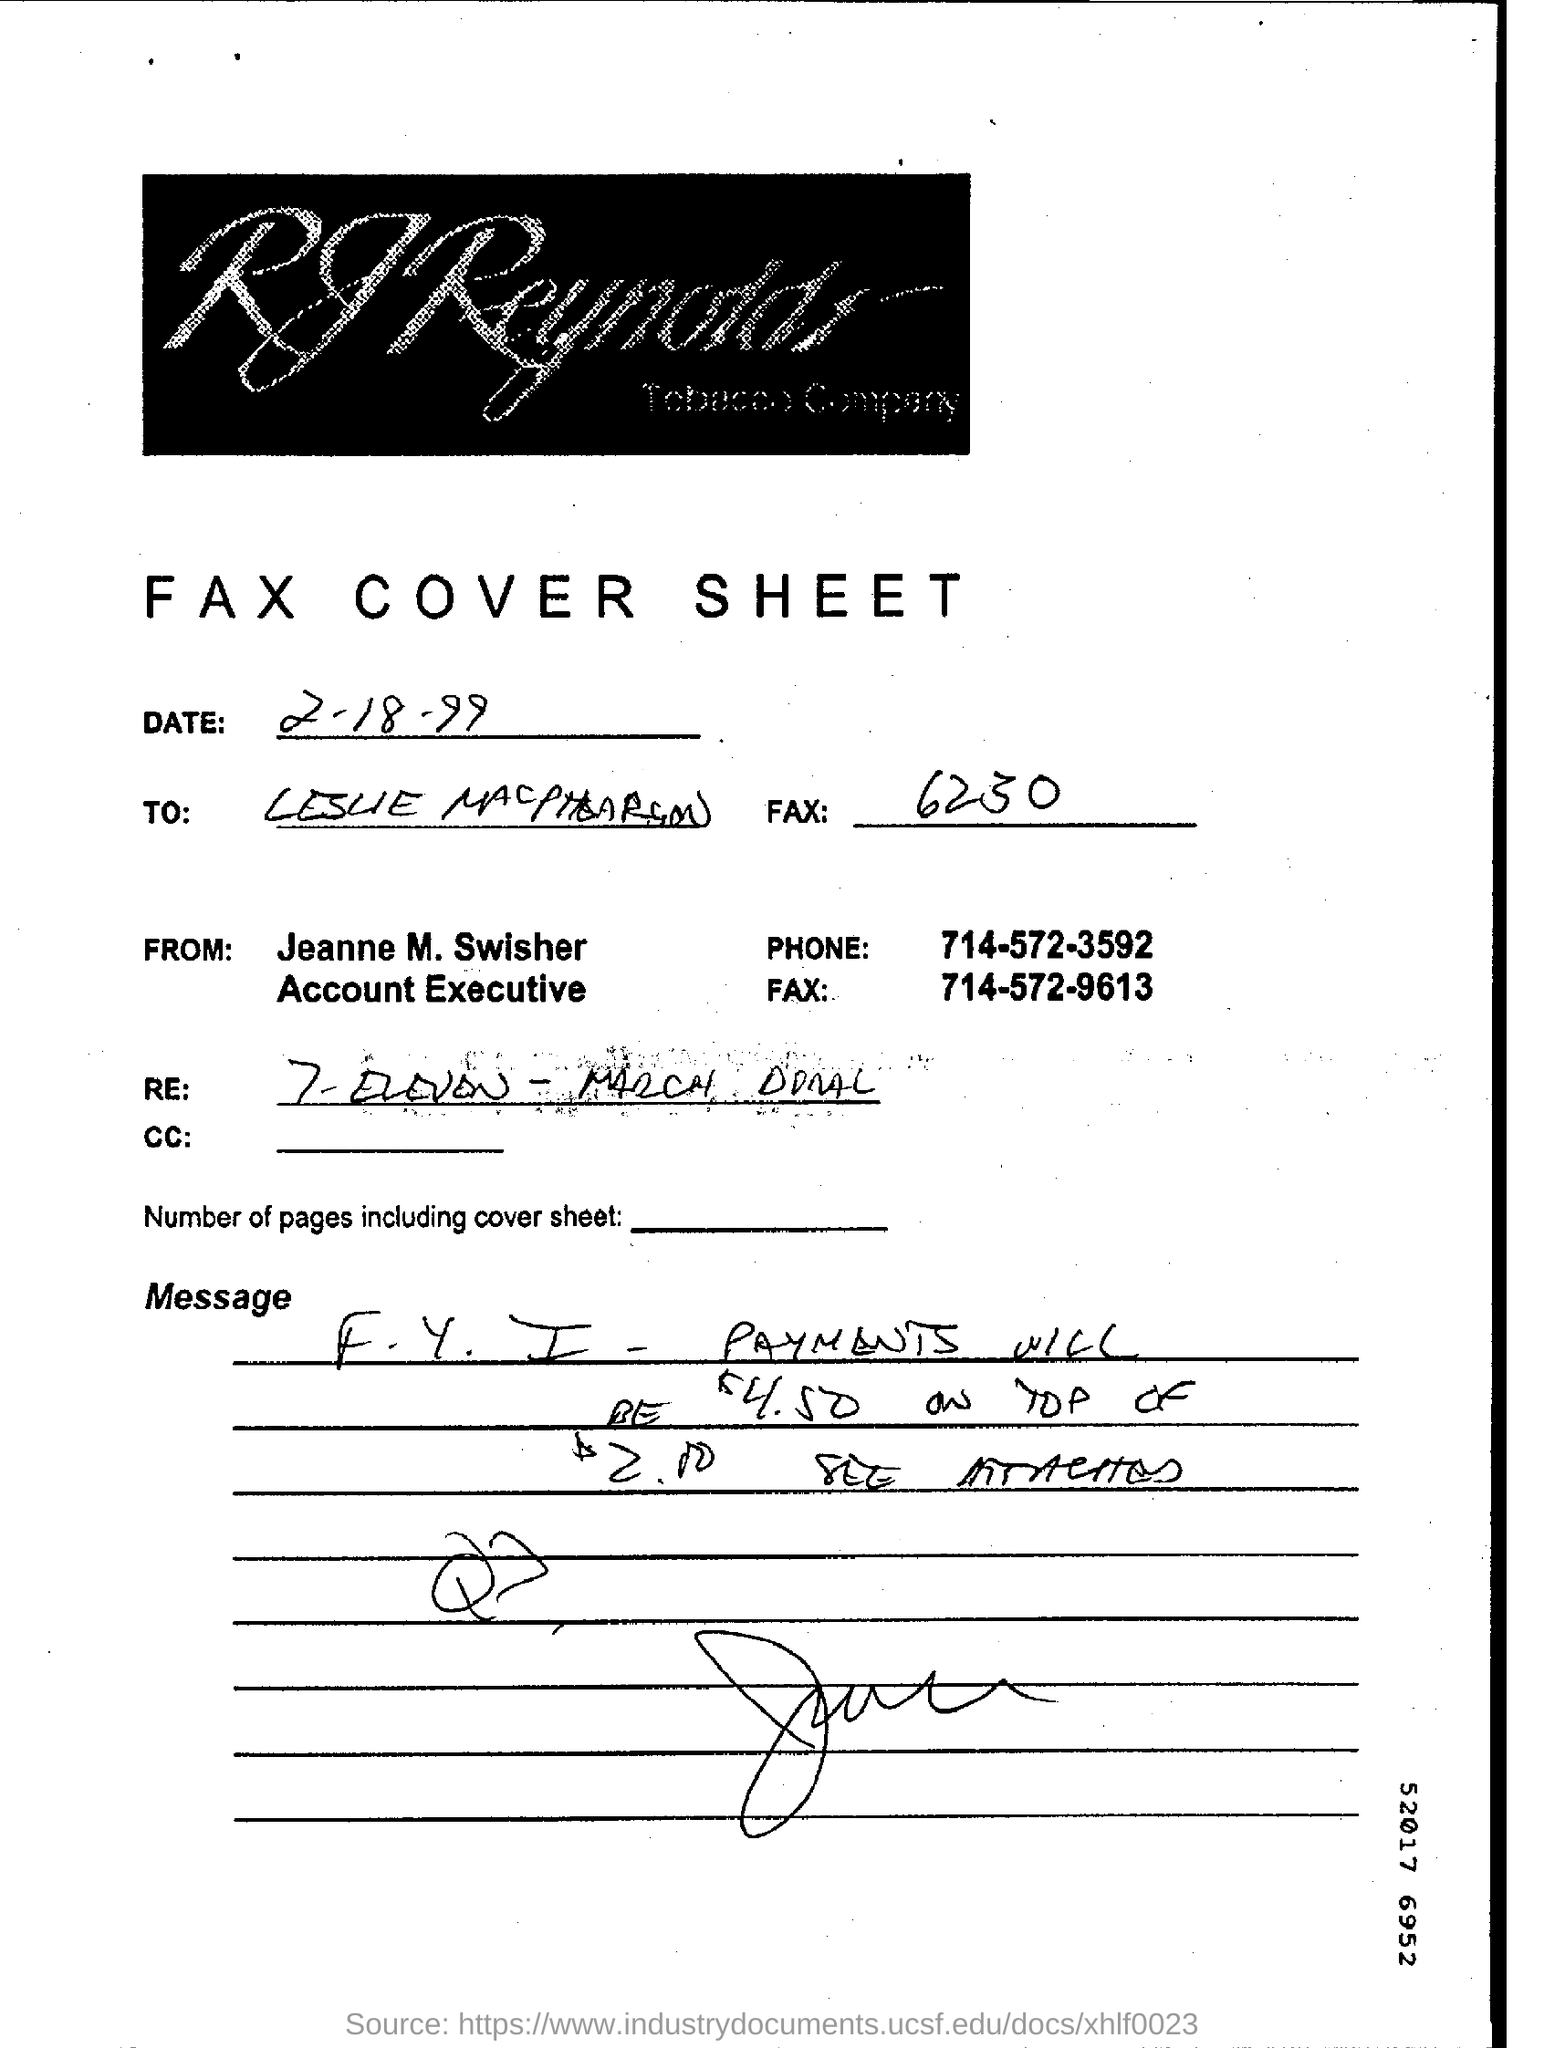Who is the account executive?
Your answer should be very brief. Jeanne M. Swisher. When is the fax cover sheet dated?
Make the answer very short. 2-18-99. What type of document is mentioned?
Give a very brief answer. Fax cover sheet. 